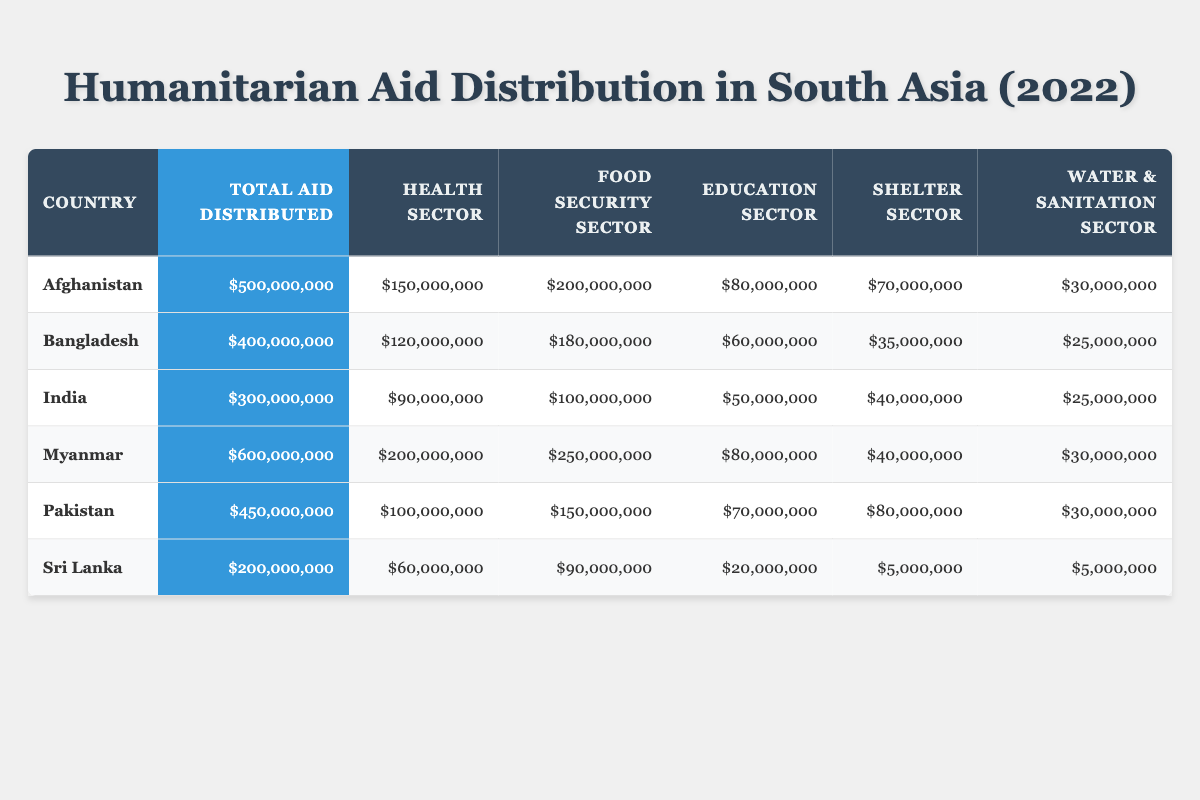What country received the highest total aid in 2022? Looking at the "Total Aid Distributed" column, Myanmar has the highest value of $600,000,000.
Answer: Myanmar Which sector received the least aid in Sri Lanka? In Sri Lanka, the "Shelter Sector" and "Water & Sanitation Sector" both received $5,000,000, the lowest among all sectors for that country.
Answer: Shelter Sector and Water & Sanitation Sector What is the total amount of aid distributed to the Health Sector across all countries? Adding up the "Health Sector" values: $150,000,000 (Afghanistan) + $120,000,000 (Bangladesh) + $90,000,000 (India) + $200,000,000 (Myanmar) + $100,000,000 (Pakistan) + $60,000,000 (Sri Lanka) = $820,000,000.
Answer: $820,000,000 How much more aid was distributed to Food Security than to Water & Sanitation in India? The "Food Security Sector" in India received $100,000,000 and the "Water & Sanitation Sector" received $25,000,000. The difference is $100,000,000 - $25,000,000 = $75,000,000.
Answer: $75,000,000 Is the total aid amount distributed in Bangladesh greater than the total aid for Sri Lanka? Bangladesh received $400,000,000 and Sri Lanka received $200,000,000. Since $400,000,000 is greater than $200,000,000, the answer is yes.
Answer: Yes What percentage of the total aid in Pakistan was allocated to the Education Sector? The total aid in Pakistan is $450,000,000. The "Education Sector" allocation is $70,000,000. To find the percentage, calculate ($70,000,000 / $450,000,000) * 100 = approximately 15.56%.
Answer: 15.56% Which country has the highest allocation for the Food Security Sector? The Food Security Sector allocation for Myanmar is $250,000,000, which is higher than all other countries listed.
Answer: Myanmar What is the total aid distributed to the shelter sector for all countries combined? Adding the values: $70,000,000 (Afghanistan) + $35,000,000 (Bangladesh) + $40,000,000 (India) + $40,000,000 (Myanmar) + $80,000,000 (Pakistan) + $5,000,000 (Sri Lanka) equals $270,000,000.
Answer: $270,000,000 How does the total aid distributed in 2022 compare between Afghanistan and Pakistan? Afghanistan received $500,000,000 and Pakistan received $450,000,000. Afghanistan's total is higher by $500,000,000 - $450,000,000 = $50,000,000.
Answer: Afghanistan is higher by $50,000,000 What is the average aid distributed per country in the Health Sector across the mentioned nations? Summing the Health Sector values: $150,000,000 + $120,000,000 + $90,000,000 + $200,000,000 + $100,000,000 + $60,000,000 = $820,000,000. There are 6 countries, so the average is $820,000,000 / 6 = approximately $136,666,667.
Answer: $136,666,667 